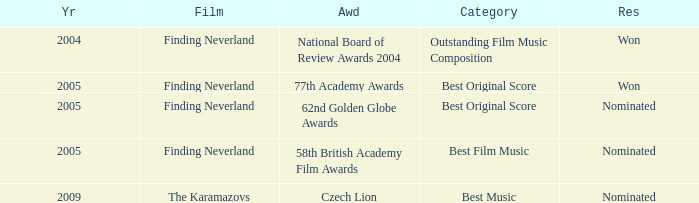Which awards happened more recently than 2005? Czech Lion. 